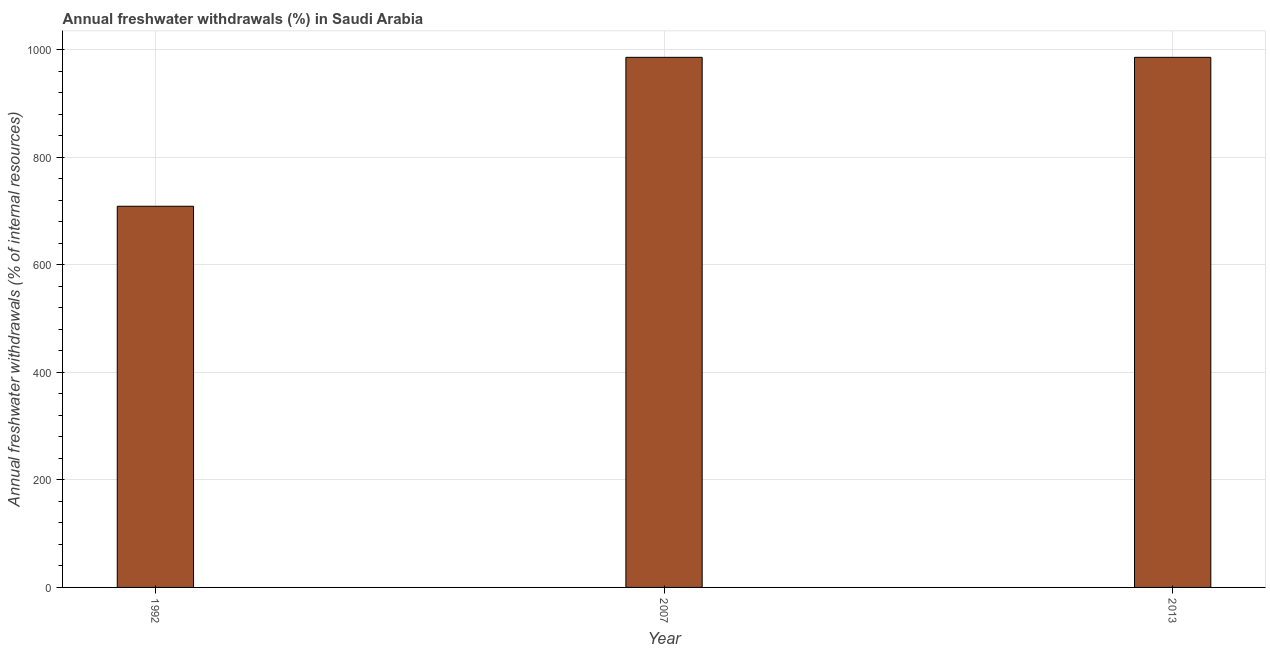What is the title of the graph?
Offer a terse response. Annual freshwater withdrawals (%) in Saudi Arabia. What is the label or title of the X-axis?
Offer a very short reply. Year. What is the label or title of the Y-axis?
Provide a succinct answer. Annual freshwater withdrawals (% of internal resources). What is the annual freshwater withdrawals in 2007?
Give a very brief answer. 986.25. Across all years, what is the maximum annual freshwater withdrawals?
Your answer should be compact. 986.25. Across all years, what is the minimum annual freshwater withdrawals?
Provide a succinct answer. 709.17. What is the sum of the annual freshwater withdrawals?
Ensure brevity in your answer.  2681.67. What is the difference between the annual freshwater withdrawals in 1992 and 2007?
Ensure brevity in your answer.  -277.08. What is the average annual freshwater withdrawals per year?
Keep it short and to the point. 893.89. What is the median annual freshwater withdrawals?
Your answer should be compact. 986.25. Do a majority of the years between 2007 and 2013 (inclusive) have annual freshwater withdrawals greater than 960 %?
Provide a succinct answer. Yes. What is the ratio of the annual freshwater withdrawals in 1992 to that in 2007?
Offer a terse response. 0.72. Is the difference between the annual freshwater withdrawals in 1992 and 2007 greater than the difference between any two years?
Give a very brief answer. Yes. What is the difference between the highest and the second highest annual freshwater withdrawals?
Offer a very short reply. 0. What is the difference between the highest and the lowest annual freshwater withdrawals?
Provide a short and direct response. 277.08. Are all the bars in the graph horizontal?
Offer a terse response. No. What is the difference between two consecutive major ticks on the Y-axis?
Offer a terse response. 200. Are the values on the major ticks of Y-axis written in scientific E-notation?
Your response must be concise. No. What is the Annual freshwater withdrawals (% of internal resources) in 1992?
Your response must be concise. 709.17. What is the Annual freshwater withdrawals (% of internal resources) in 2007?
Give a very brief answer. 986.25. What is the Annual freshwater withdrawals (% of internal resources) of 2013?
Your answer should be very brief. 986.25. What is the difference between the Annual freshwater withdrawals (% of internal resources) in 1992 and 2007?
Ensure brevity in your answer.  -277.08. What is the difference between the Annual freshwater withdrawals (% of internal resources) in 1992 and 2013?
Provide a succinct answer. -277.08. What is the difference between the Annual freshwater withdrawals (% of internal resources) in 2007 and 2013?
Provide a succinct answer. 0. What is the ratio of the Annual freshwater withdrawals (% of internal resources) in 1992 to that in 2007?
Give a very brief answer. 0.72. What is the ratio of the Annual freshwater withdrawals (% of internal resources) in 1992 to that in 2013?
Provide a short and direct response. 0.72. What is the ratio of the Annual freshwater withdrawals (% of internal resources) in 2007 to that in 2013?
Your answer should be very brief. 1. 